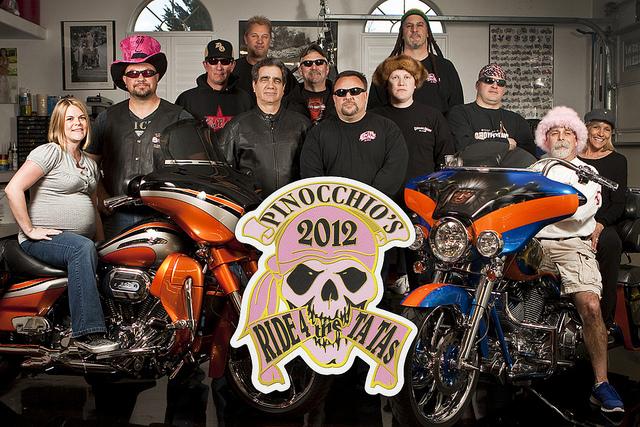What year was the photo taken?
Quick response, please. 2012. What color is the man shirt on the bike?
Write a very short answer. White. What cause did they fundraise for?
Quick response, please. Breast cancer. 